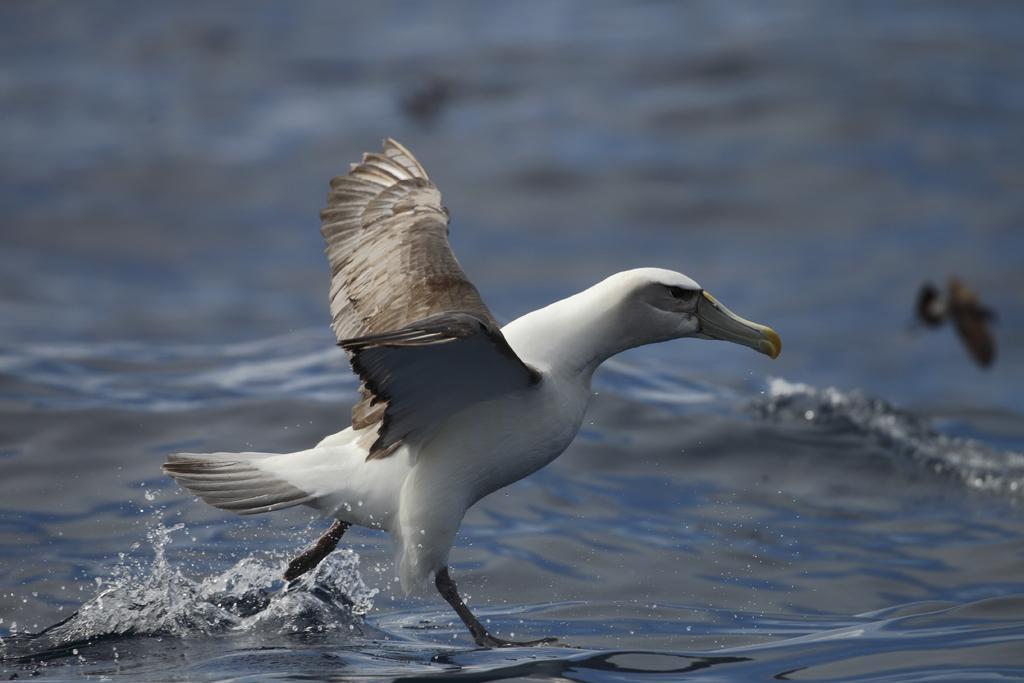How would you summarize this image in a sentence or two? In this image we can see a bird standing on the water. 